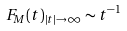<formula> <loc_0><loc_0><loc_500><loc_500>F _ { M } ( t ) _ { | t | \to \infty } \sim t ^ { - 1 }</formula> 